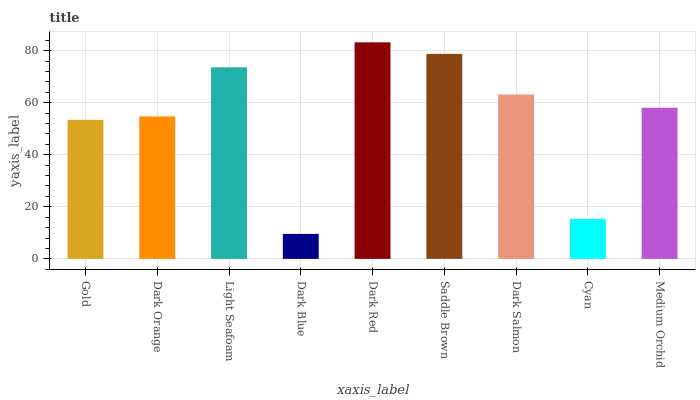Is Dark Blue the minimum?
Answer yes or no. Yes. Is Dark Red the maximum?
Answer yes or no. Yes. Is Dark Orange the minimum?
Answer yes or no. No. Is Dark Orange the maximum?
Answer yes or no. No. Is Dark Orange greater than Gold?
Answer yes or no. Yes. Is Gold less than Dark Orange?
Answer yes or no. Yes. Is Gold greater than Dark Orange?
Answer yes or no. No. Is Dark Orange less than Gold?
Answer yes or no. No. Is Medium Orchid the high median?
Answer yes or no. Yes. Is Medium Orchid the low median?
Answer yes or no. Yes. Is Light Seafoam the high median?
Answer yes or no. No. Is Dark Red the low median?
Answer yes or no. No. 